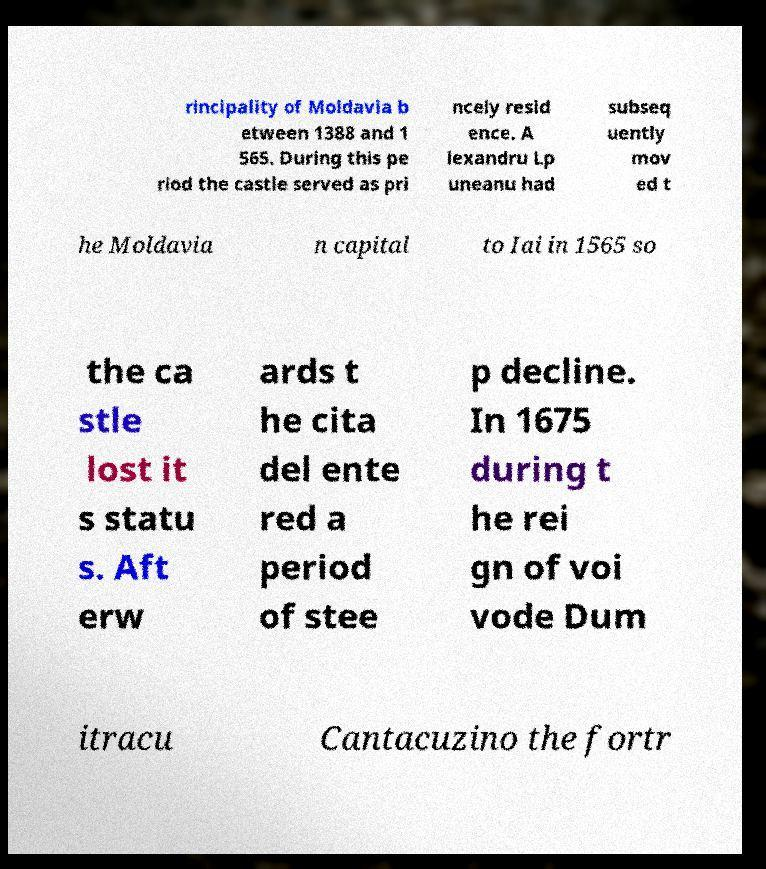There's text embedded in this image that I need extracted. Can you transcribe it verbatim? rincipality of Moldavia b etween 1388 and 1 565. During this pe riod the castle served as pri ncely resid ence. A lexandru Lp uneanu had subseq uently mov ed t he Moldavia n capital to Iai in 1565 so the ca stle lost it s statu s. Aft erw ards t he cita del ente red a period of stee p decline. In 1675 during t he rei gn of voi vode Dum itracu Cantacuzino the fortr 